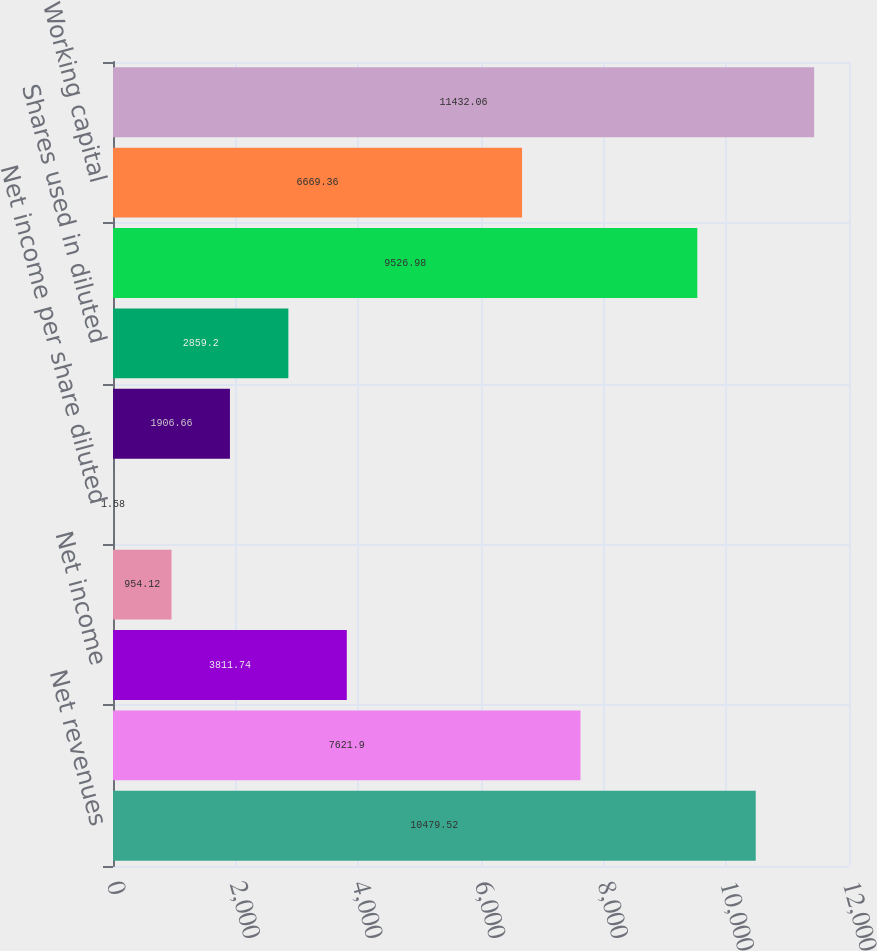<chart> <loc_0><loc_0><loc_500><loc_500><bar_chart><fcel>Net revenues<fcel>Gross profit<fcel>Net income<fcel>Net income per share basic<fcel>Net income per share diluted<fcel>Shares used in basic<fcel>Shares used in diluted<fcel>Cash cash equivalents and<fcel>Working capital<fcel>Total assets<nl><fcel>10479.5<fcel>7621.9<fcel>3811.74<fcel>954.12<fcel>1.58<fcel>1906.66<fcel>2859.2<fcel>9526.98<fcel>6669.36<fcel>11432.1<nl></chart> 